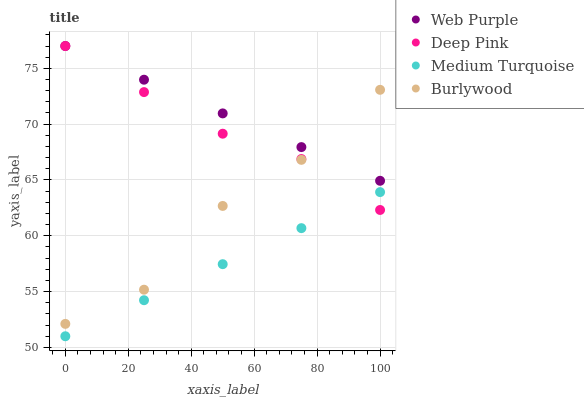Does Medium Turquoise have the minimum area under the curve?
Answer yes or no. Yes. Does Web Purple have the maximum area under the curve?
Answer yes or no. Yes. Does Deep Pink have the minimum area under the curve?
Answer yes or no. No. Does Deep Pink have the maximum area under the curve?
Answer yes or no. No. Is Web Purple the smoothest?
Answer yes or no. Yes. Is Burlywood the roughest?
Answer yes or no. Yes. Is Deep Pink the smoothest?
Answer yes or no. No. Is Deep Pink the roughest?
Answer yes or no. No. Does Medium Turquoise have the lowest value?
Answer yes or no. Yes. Does Deep Pink have the lowest value?
Answer yes or no. No. Does Deep Pink have the highest value?
Answer yes or no. Yes. Does Medium Turquoise have the highest value?
Answer yes or no. No. Is Medium Turquoise less than Burlywood?
Answer yes or no. Yes. Is Burlywood greater than Medium Turquoise?
Answer yes or no. Yes. Does Burlywood intersect Deep Pink?
Answer yes or no. Yes. Is Burlywood less than Deep Pink?
Answer yes or no. No. Is Burlywood greater than Deep Pink?
Answer yes or no. No. Does Medium Turquoise intersect Burlywood?
Answer yes or no. No. 